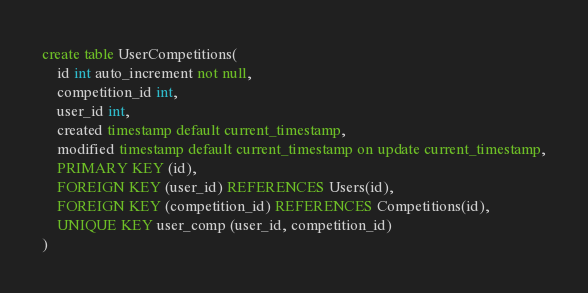<code> <loc_0><loc_0><loc_500><loc_500><_SQL_>create table UserCompetitions(
    id int auto_increment not null,
    competition_id int,
    user_id int,
    created timestamp default current_timestamp,
    modified timestamp default current_timestamp on update current_timestamp,
    PRIMARY KEY (id),
    FOREIGN KEY (user_id) REFERENCES Users(id),
    FOREIGN KEY (competition_id) REFERENCES Competitions(id),
    UNIQUE KEY user_comp (user_id, competition_id)
)</code> 